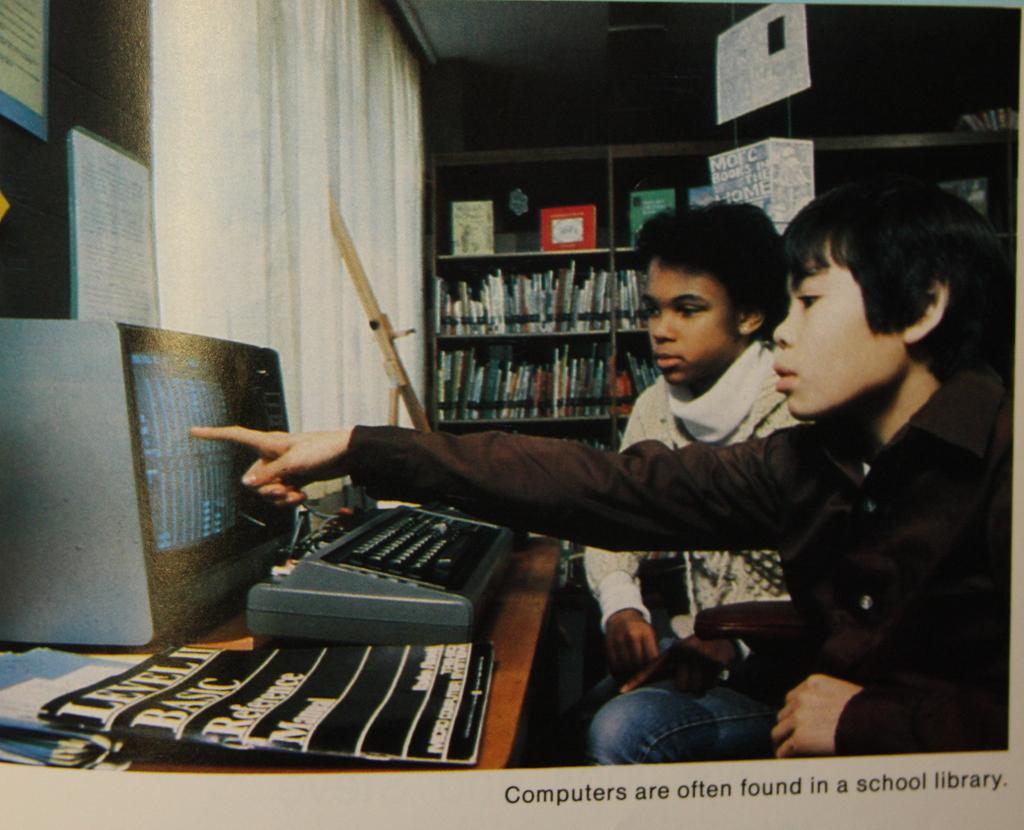Provide a one-sentence caption for the provided image. A photo of two boys that is captioned Computers are often found in a school library. 